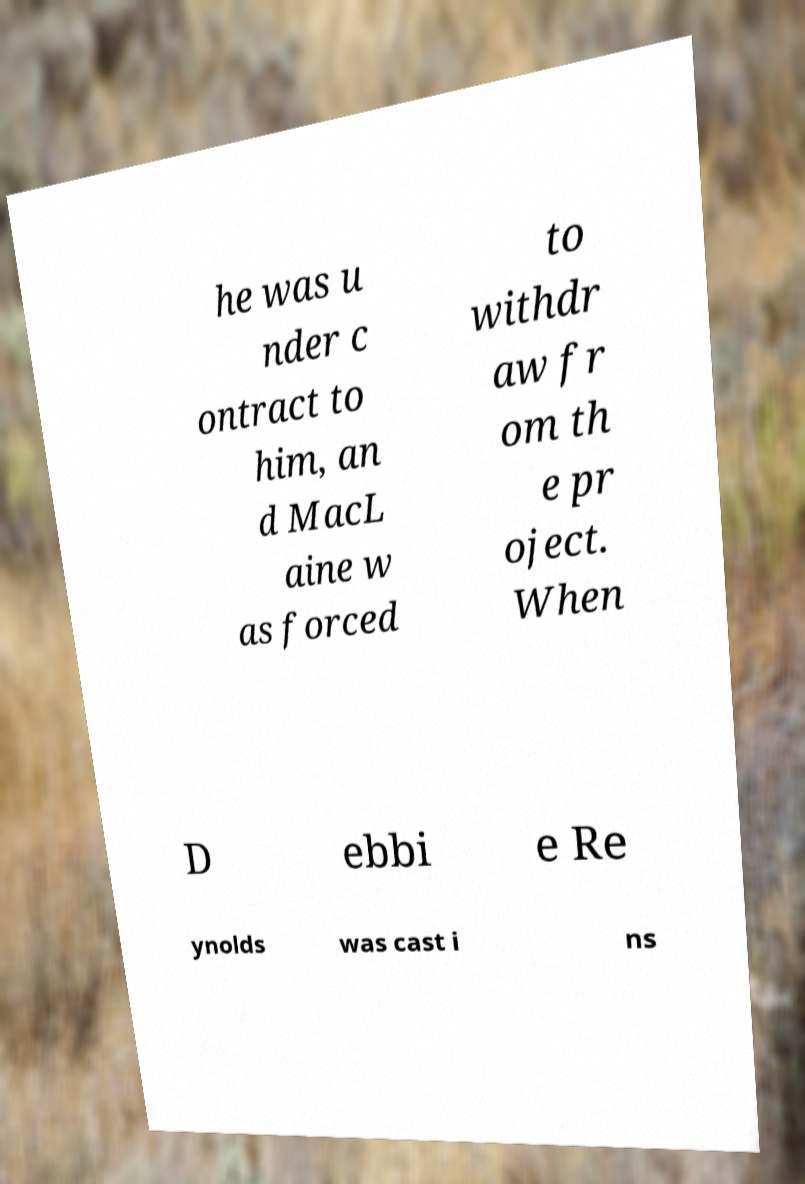Could you assist in decoding the text presented in this image and type it out clearly? he was u nder c ontract to him, an d MacL aine w as forced to withdr aw fr om th e pr oject. When D ebbi e Re ynolds was cast i ns 